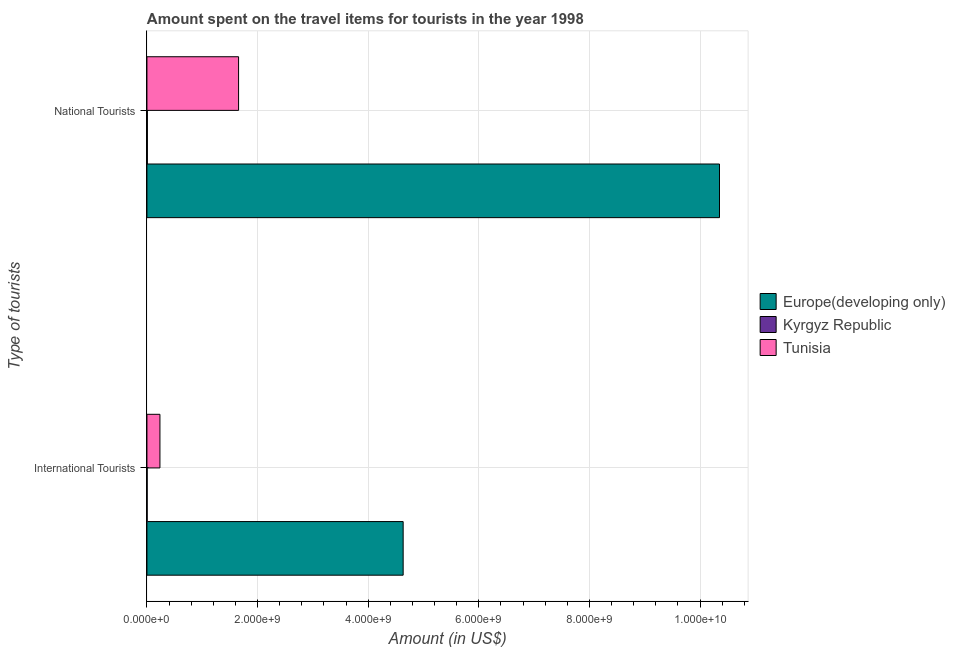How many different coloured bars are there?
Your response must be concise. 3. Are the number of bars on each tick of the Y-axis equal?
Ensure brevity in your answer.  Yes. How many bars are there on the 1st tick from the bottom?
Provide a succinct answer. 3. What is the label of the 2nd group of bars from the top?
Your answer should be compact. International Tourists. Across all countries, what is the maximum amount spent on travel items of national tourists?
Keep it short and to the point. 1.04e+1. Across all countries, what is the minimum amount spent on travel items of international tourists?
Ensure brevity in your answer.  4.00e+06. In which country was the amount spent on travel items of international tourists maximum?
Your answer should be very brief. Europe(developing only). In which country was the amount spent on travel items of national tourists minimum?
Give a very brief answer. Kyrgyz Republic. What is the total amount spent on travel items of international tourists in the graph?
Provide a succinct answer. 4.87e+09. What is the difference between the amount spent on travel items of national tourists in Kyrgyz Republic and that in Europe(developing only)?
Provide a succinct answer. -1.03e+1. What is the difference between the amount spent on travel items of international tourists in Kyrgyz Republic and the amount spent on travel items of national tourists in Tunisia?
Provide a short and direct response. -1.65e+09. What is the average amount spent on travel items of national tourists per country?
Provide a succinct answer. 4.01e+09. What is the difference between the amount spent on travel items of national tourists and amount spent on travel items of international tourists in Europe(developing only)?
Provide a succinct answer. 5.72e+09. What is the ratio of the amount spent on travel items of international tourists in Kyrgyz Republic to that in Tunisia?
Make the answer very short. 0.02. In how many countries, is the amount spent on travel items of international tourists greater than the average amount spent on travel items of international tourists taken over all countries?
Your answer should be very brief. 1. What does the 1st bar from the top in National Tourists represents?
Give a very brief answer. Tunisia. What does the 2nd bar from the bottom in National Tourists represents?
Offer a very short reply. Kyrgyz Republic. How many bars are there?
Provide a succinct answer. 6. Are all the bars in the graph horizontal?
Your answer should be compact. Yes. Where does the legend appear in the graph?
Give a very brief answer. Center right. What is the title of the graph?
Ensure brevity in your answer.  Amount spent on the travel items for tourists in the year 1998. Does "Central Europe" appear as one of the legend labels in the graph?
Offer a terse response. No. What is the label or title of the X-axis?
Your answer should be compact. Amount (in US$). What is the label or title of the Y-axis?
Your answer should be compact. Type of tourists. What is the Amount (in US$) of Europe(developing only) in International Tourists?
Your answer should be compact. 4.63e+09. What is the Amount (in US$) of Tunisia in International Tourists?
Ensure brevity in your answer.  2.35e+08. What is the Amount (in US$) of Europe(developing only) in National Tourists?
Offer a terse response. 1.04e+1. What is the Amount (in US$) of Kyrgyz Republic in National Tourists?
Your response must be concise. 8.00e+06. What is the Amount (in US$) of Tunisia in National Tourists?
Give a very brief answer. 1.66e+09. Across all Type of tourists, what is the maximum Amount (in US$) in Europe(developing only)?
Give a very brief answer. 1.04e+1. Across all Type of tourists, what is the maximum Amount (in US$) in Tunisia?
Offer a very short reply. 1.66e+09. Across all Type of tourists, what is the minimum Amount (in US$) of Europe(developing only)?
Your answer should be very brief. 4.63e+09. Across all Type of tourists, what is the minimum Amount (in US$) of Kyrgyz Republic?
Offer a very short reply. 4.00e+06. Across all Type of tourists, what is the minimum Amount (in US$) in Tunisia?
Your answer should be compact. 2.35e+08. What is the total Amount (in US$) in Europe(developing only) in the graph?
Your answer should be very brief. 1.50e+1. What is the total Amount (in US$) in Kyrgyz Republic in the graph?
Offer a terse response. 1.20e+07. What is the total Amount (in US$) in Tunisia in the graph?
Make the answer very short. 1.89e+09. What is the difference between the Amount (in US$) in Europe(developing only) in International Tourists and that in National Tourists?
Give a very brief answer. -5.72e+09. What is the difference between the Amount (in US$) of Kyrgyz Republic in International Tourists and that in National Tourists?
Your response must be concise. -4.00e+06. What is the difference between the Amount (in US$) in Tunisia in International Tourists and that in National Tourists?
Offer a very short reply. -1.42e+09. What is the difference between the Amount (in US$) of Europe(developing only) in International Tourists and the Amount (in US$) of Kyrgyz Republic in National Tourists?
Offer a very short reply. 4.62e+09. What is the difference between the Amount (in US$) of Europe(developing only) in International Tourists and the Amount (in US$) of Tunisia in National Tourists?
Your response must be concise. 2.98e+09. What is the difference between the Amount (in US$) in Kyrgyz Republic in International Tourists and the Amount (in US$) in Tunisia in National Tourists?
Make the answer very short. -1.65e+09. What is the average Amount (in US$) in Europe(developing only) per Type of tourists?
Make the answer very short. 7.49e+09. What is the average Amount (in US$) in Tunisia per Type of tourists?
Ensure brevity in your answer.  9.46e+08. What is the difference between the Amount (in US$) of Europe(developing only) and Amount (in US$) of Kyrgyz Republic in International Tourists?
Ensure brevity in your answer.  4.63e+09. What is the difference between the Amount (in US$) in Europe(developing only) and Amount (in US$) in Tunisia in International Tourists?
Offer a very short reply. 4.40e+09. What is the difference between the Amount (in US$) of Kyrgyz Republic and Amount (in US$) of Tunisia in International Tourists?
Offer a terse response. -2.31e+08. What is the difference between the Amount (in US$) in Europe(developing only) and Amount (in US$) in Kyrgyz Republic in National Tourists?
Offer a terse response. 1.03e+1. What is the difference between the Amount (in US$) in Europe(developing only) and Amount (in US$) in Tunisia in National Tourists?
Offer a terse response. 8.70e+09. What is the difference between the Amount (in US$) of Kyrgyz Republic and Amount (in US$) of Tunisia in National Tourists?
Make the answer very short. -1.65e+09. What is the ratio of the Amount (in US$) in Europe(developing only) in International Tourists to that in National Tourists?
Your response must be concise. 0.45. What is the ratio of the Amount (in US$) in Kyrgyz Republic in International Tourists to that in National Tourists?
Provide a short and direct response. 0.5. What is the ratio of the Amount (in US$) in Tunisia in International Tourists to that in National Tourists?
Offer a terse response. 0.14. What is the difference between the highest and the second highest Amount (in US$) of Europe(developing only)?
Offer a very short reply. 5.72e+09. What is the difference between the highest and the second highest Amount (in US$) of Kyrgyz Republic?
Give a very brief answer. 4.00e+06. What is the difference between the highest and the second highest Amount (in US$) in Tunisia?
Keep it short and to the point. 1.42e+09. What is the difference between the highest and the lowest Amount (in US$) in Europe(developing only)?
Provide a short and direct response. 5.72e+09. What is the difference between the highest and the lowest Amount (in US$) in Tunisia?
Ensure brevity in your answer.  1.42e+09. 